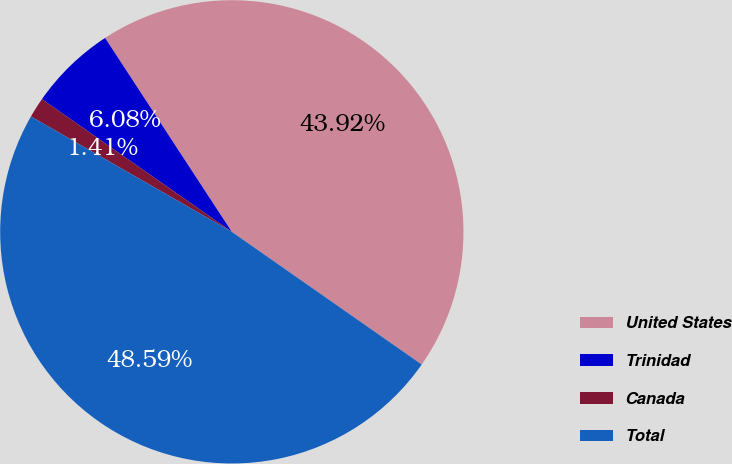Convert chart to OTSL. <chart><loc_0><loc_0><loc_500><loc_500><pie_chart><fcel>United States<fcel>Trinidad<fcel>Canada<fcel>Total<nl><fcel>43.92%<fcel>6.08%<fcel>1.41%<fcel>48.59%<nl></chart> 